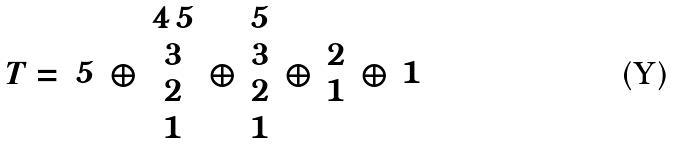<formula> <loc_0><loc_0><loc_500><loc_500>T = { \begin{array} { c } 5 \end{array} } \oplus { \begin{array} { c } 4 \, 5 \\ 3 \\ 2 \\ 1 \end{array} } \oplus { \begin{array} { c } 5 \\ 3 \\ 2 \\ 1 \end{array} } \oplus { \begin{array} { c } 2 \\ 1 \end{array} } \oplus { \begin{array} { c } 1 \end{array} }</formula> 